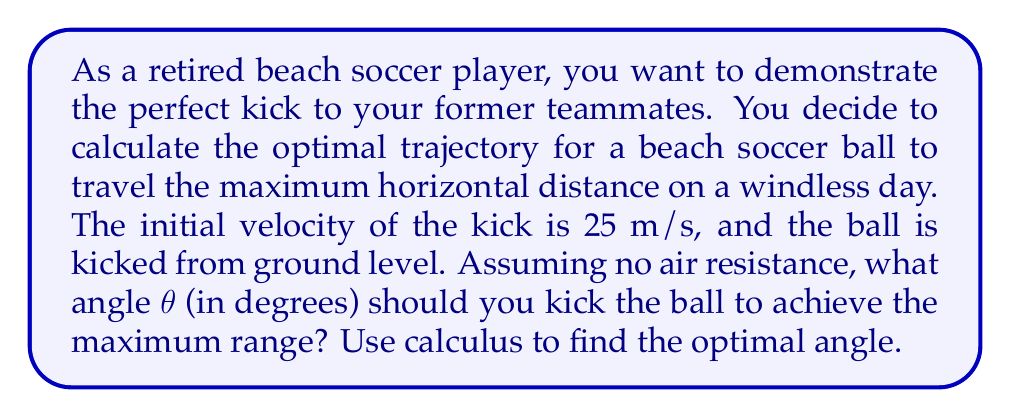Help me with this question. Let's approach this step-by-step using calculus:

1) The range (R) of a projectile launched at an angle θ with initial velocity v₀ is given by:

   $$R = \frac{v_0^2 \sin(2\theta)}{g}$$

   where g is the acceleration due to gravity (9.8 m/s²).

2) To find the maximum range, we need to find the angle θ that maximizes this function. We can do this by taking the derivative of R with respect to θ and setting it equal to zero.

3) First, let's simplify our equation by replacing the constants with a single constant k:

   $$R = k \sin(2\theta) \text{ where } k = \frac{v_0^2}{g}$$

4) Now, let's take the derivative:

   $$\frac{dR}{d\theta} = k \cdot 2\cos(2\theta)$$

5) Set this equal to zero and solve for θ:

   $$k \cdot 2\cos(2\theta) = 0$$
   $$\cos(2\theta) = 0$$

6) The cosine function equals zero when its argument is π/2 or 3π/2 radians. Since we're dealing with a launch angle, we're interested in the solution in the first quadrant:

   $$2\theta = \frac{\pi}{2}$$
   $$\theta = \frac{\pi}{4} = 45°$$

7) To confirm this is a maximum (not a minimum), we can check the second derivative:

   $$\frac{d^2R}{d\theta^2} = k \cdot (-4\sin(2\theta))$$

   At θ = 45°, this is negative, confirming a maximum.

8) Therefore, the optimal angle for maximum range is 45°.
Answer: 45° 